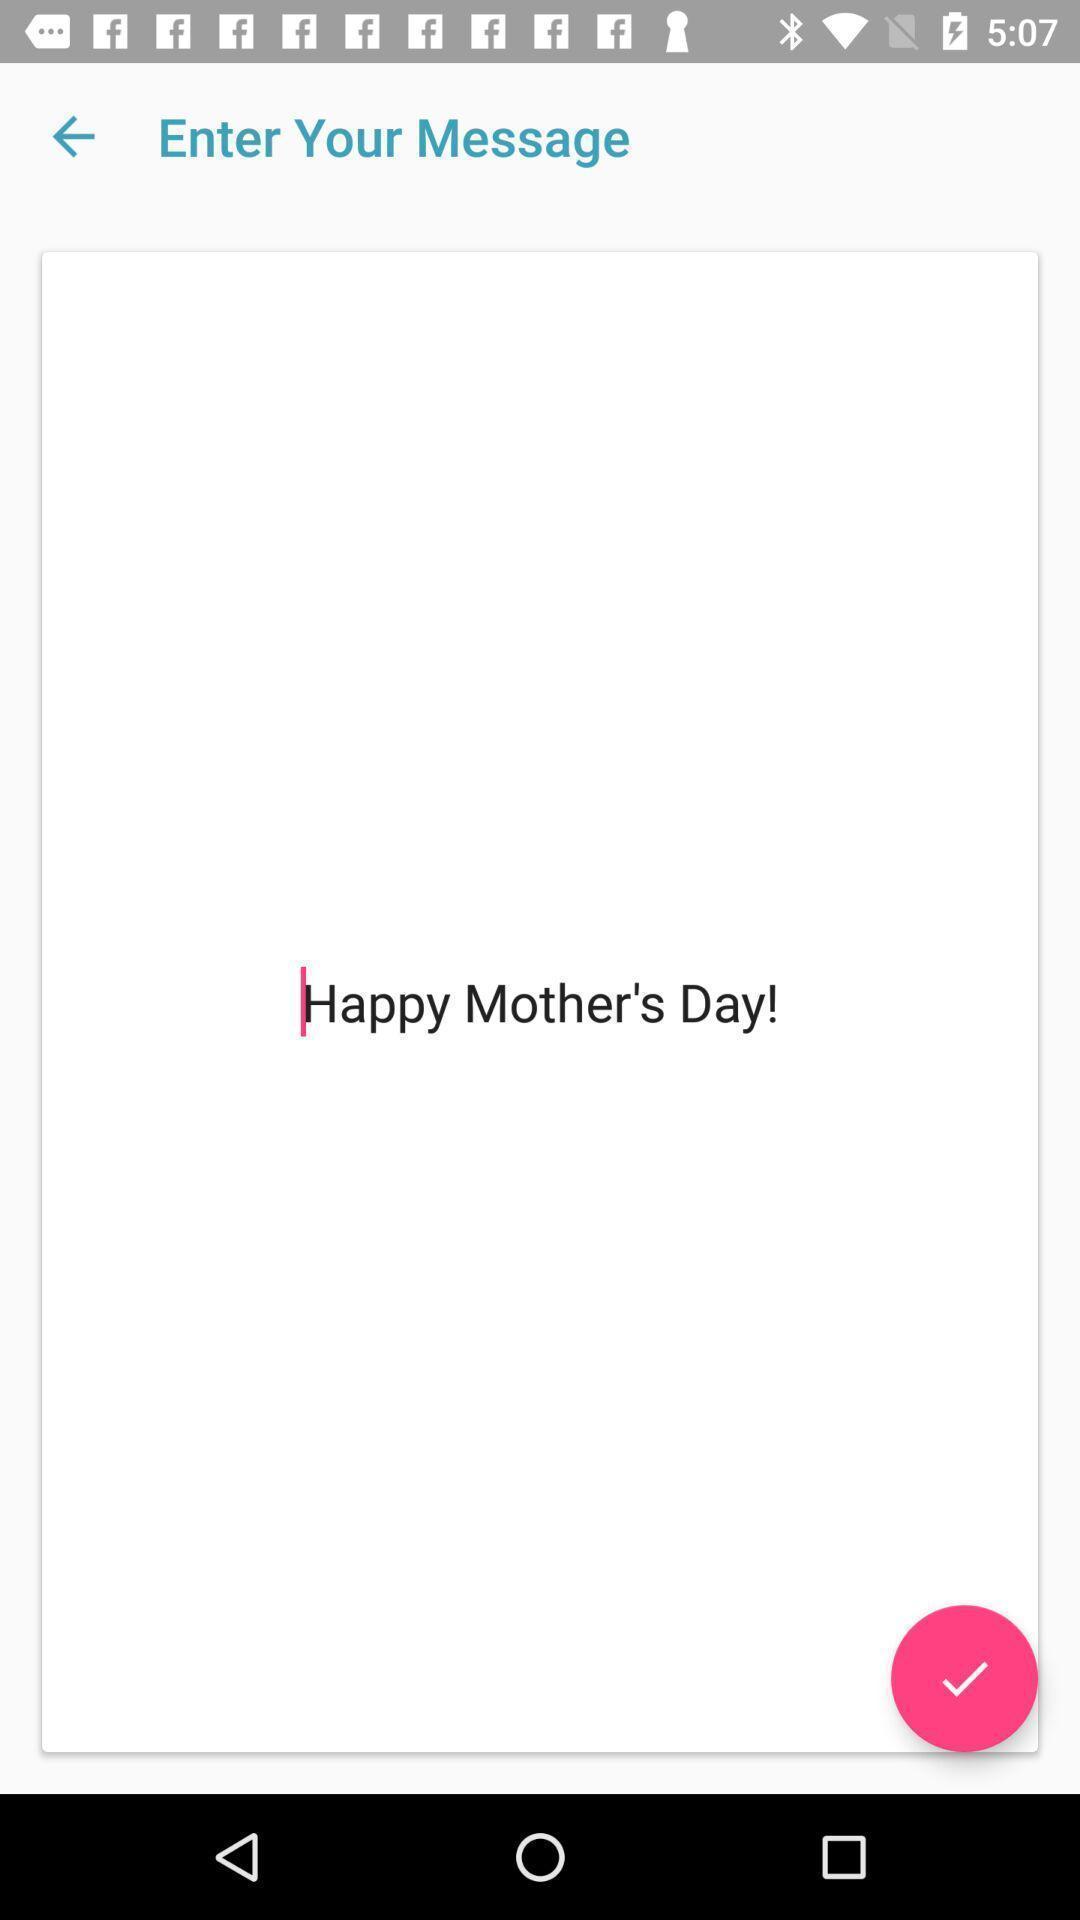Please provide a description for this image. Screen displaying the message entered. 